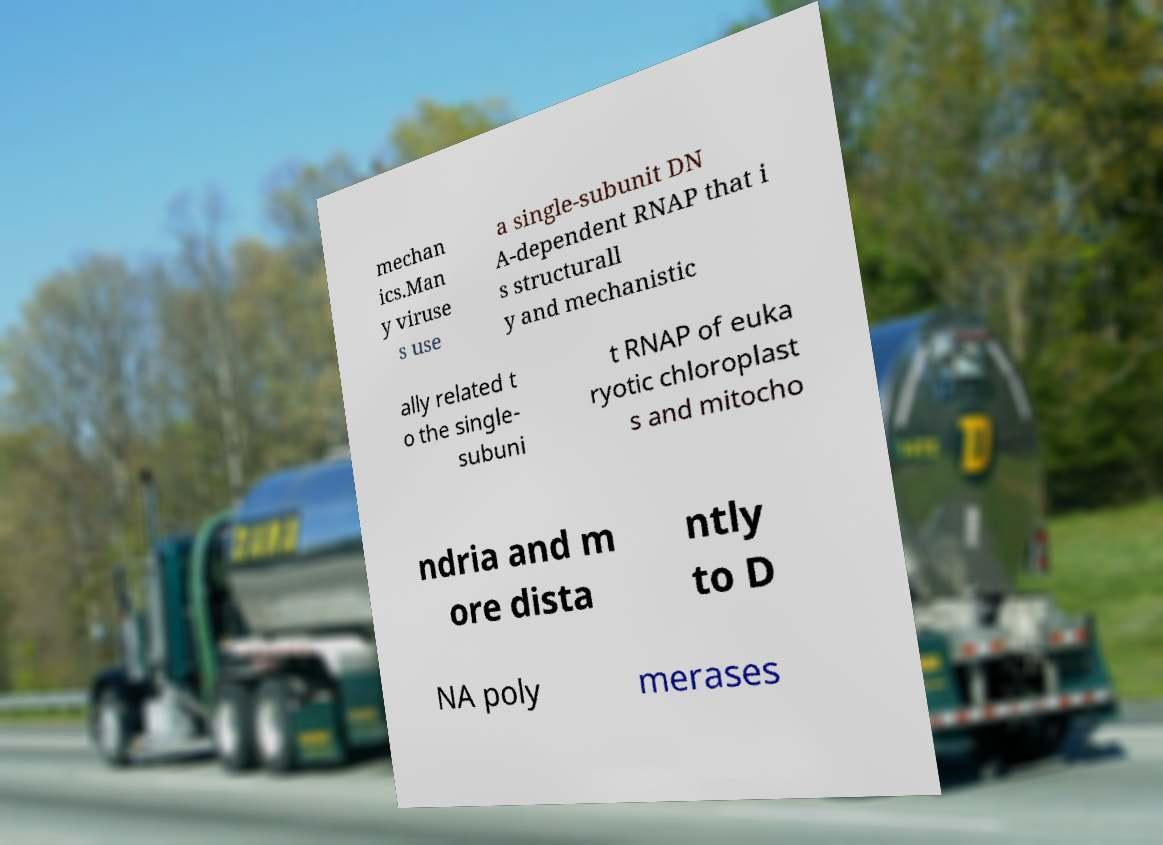What messages or text are displayed in this image? I need them in a readable, typed format. mechan ics.Man y viruse s use a single-subunit DN A-dependent RNAP that i s structurall y and mechanistic ally related t o the single- subuni t RNAP of euka ryotic chloroplast s and mitocho ndria and m ore dista ntly to D NA poly merases 